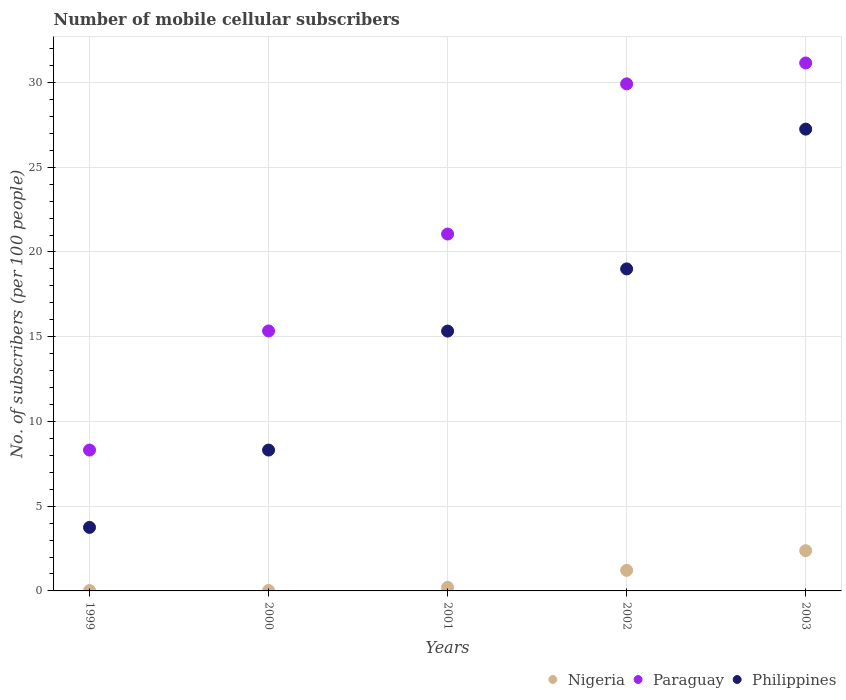How many different coloured dotlines are there?
Give a very brief answer. 3. What is the number of mobile cellular subscribers in Philippines in 2003?
Your answer should be compact. 27.25. Across all years, what is the maximum number of mobile cellular subscribers in Nigeria?
Make the answer very short. 2.38. Across all years, what is the minimum number of mobile cellular subscribers in Philippines?
Offer a terse response. 3.75. In which year was the number of mobile cellular subscribers in Philippines minimum?
Offer a very short reply. 1999. What is the total number of mobile cellular subscribers in Nigeria in the graph?
Your answer should be very brief. 3.85. What is the difference between the number of mobile cellular subscribers in Philippines in 2000 and that in 2003?
Give a very brief answer. -18.94. What is the difference between the number of mobile cellular subscribers in Nigeria in 2003 and the number of mobile cellular subscribers in Philippines in 1999?
Your response must be concise. -1.37. What is the average number of mobile cellular subscribers in Philippines per year?
Your answer should be compact. 14.73. In the year 1999, what is the difference between the number of mobile cellular subscribers in Philippines and number of mobile cellular subscribers in Nigeria?
Offer a terse response. 3.73. In how many years, is the number of mobile cellular subscribers in Philippines greater than 20?
Provide a short and direct response. 1. What is the ratio of the number of mobile cellular subscribers in Nigeria in 1999 to that in 2000?
Provide a short and direct response. 0.85. Is the difference between the number of mobile cellular subscribers in Philippines in 1999 and 2000 greater than the difference between the number of mobile cellular subscribers in Nigeria in 1999 and 2000?
Your response must be concise. No. What is the difference between the highest and the second highest number of mobile cellular subscribers in Nigeria?
Your answer should be very brief. 1.16. What is the difference between the highest and the lowest number of mobile cellular subscribers in Paraguay?
Offer a terse response. 22.84. Is it the case that in every year, the sum of the number of mobile cellular subscribers in Paraguay and number of mobile cellular subscribers in Philippines  is greater than the number of mobile cellular subscribers in Nigeria?
Give a very brief answer. Yes. Is the number of mobile cellular subscribers in Nigeria strictly less than the number of mobile cellular subscribers in Paraguay over the years?
Provide a succinct answer. Yes. Are the values on the major ticks of Y-axis written in scientific E-notation?
Offer a terse response. No. How are the legend labels stacked?
Provide a short and direct response. Horizontal. What is the title of the graph?
Your answer should be compact. Number of mobile cellular subscribers. What is the label or title of the Y-axis?
Give a very brief answer. No. of subscribers (per 100 people). What is the No. of subscribers (per 100 people) of Nigeria in 1999?
Offer a very short reply. 0.02. What is the No. of subscribers (per 100 people) of Paraguay in 1999?
Provide a succinct answer. 8.31. What is the No. of subscribers (per 100 people) of Philippines in 1999?
Keep it short and to the point. 3.75. What is the No. of subscribers (per 100 people) of Nigeria in 2000?
Provide a short and direct response. 0.02. What is the No. of subscribers (per 100 people) of Paraguay in 2000?
Your answer should be very brief. 15.34. What is the No. of subscribers (per 100 people) of Philippines in 2000?
Your response must be concise. 8.31. What is the No. of subscribers (per 100 people) of Nigeria in 2001?
Offer a terse response. 0.21. What is the No. of subscribers (per 100 people) in Paraguay in 2001?
Make the answer very short. 21.06. What is the No. of subscribers (per 100 people) of Philippines in 2001?
Ensure brevity in your answer.  15.33. What is the No. of subscribers (per 100 people) in Nigeria in 2002?
Provide a short and direct response. 1.21. What is the No. of subscribers (per 100 people) of Paraguay in 2002?
Provide a succinct answer. 29.92. What is the No. of subscribers (per 100 people) in Philippines in 2002?
Your answer should be very brief. 19. What is the No. of subscribers (per 100 people) in Nigeria in 2003?
Ensure brevity in your answer.  2.38. What is the No. of subscribers (per 100 people) in Paraguay in 2003?
Ensure brevity in your answer.  31.16. What is the No. of subscribers (per 100 people) of Philippines in 2003?
Keep it short and to the point. 27.25. Across all years, what is the maximum No. of subscribers (per 100 people) in Nigeria?
Provide a short and direct response. 2.38. Across all years, what is the maximum No. of subscribers (per 100 people) of Paraguay?
Ensure brevity in your answer.  31.16. Across all years, what is the maximum No. of subscribers (per 100 people) of Philippines?
Give a very brief answer. 27.25. Across all years, what is the minimum No. of subscribers (per 100 people) in Nigeria?
Give a very brief answer. 0.02. Across all years, what is the minimum No. of subscribers (per 100 people) in Paraguay?
Provide a short and direct response. 8.31. Across all years, what is the minimum No. of subscribers (per 100 people) of Philippines?
Make the answer very short. 3.75. What is the total No. of subscribers (per 100 people) of Nigeria in the graph?
Your response must be concise. 3.85. What is the total No. of subscribers (per 100 people) in Paraguay in the graph?
Provide a short and direct response. 105.79. What is the total No. of subscribers (per 100 people) of Philippines in the graph?
Offer a very short reply. 73.65. What is the difference between the No. of subscribers (per 100 people) in Nigeria in 1999 and that in 2000?
Ensure brevity in your answer.  -0. What is the difference between the No. of subscribers (per 100 people) in Paraguay in 1999 and that in 2000?
Offer a very short reply. -7.03. What is the difference between the No. of subscribers (per 100 people) of Philippines in 1999 and that in 2000?
Provide a succinct answer. -4.56. What is the difference between the No. of subscribers (per 100 people) in Nigeria in 1999 and that in 2001?
Give a very brief answer. -0.19. What is the difference between the No. of subscribers (per 100 people) in Paraguay in 1999 and that in 2001?
Keep it short and to the point. -12.75. What is the difference between the No. of subscribers (per 100 people) in Philippines in 1999 and that in 2001?
Your response must be concise. -11.58. What is the difference between the No. of subscribers (per 100 people) in Nigeria in 1999 and that in 2002?
Provide a succinct answer. -1.19. What is the difference between the No. of subscribers (per 100 people) in Paraguay in 1999 and that in 2002?
Give a very brief answer. -21.61. What is the difference between the No. of subscribers (per 100 people) in Philippines in 1999 and that in 2002?
Offer a terse response. -15.25. What is the difference between the No. of subscribers (per 100 people) of Nigeria in 1999 and that in 2003?
Your response must be concise. -2.36. What is the difference between the No. of subscribers (per 100 people) of Paraguay in 1999 and that in 2003?
Ensure brevity in your answer.  -22.84. What is the difference between the No. of subscribers (per 100 people) of Philippines in 1999 and that in 2003?
Ensure brevity in your answer.  -23.5. What is the difference between the No. of subscribers (per 100 people) of Nigeria in 2000 and that in 2001?
Your answer should be compact. -0.19. What is the difference between the No. of subscribers (per 100 people) in Paraguay in 2000 and that in 2001?
Your answer should be compact. -5.72. What is the difference between the No. of subscribers (per 100 people) of Philippines in 2000 and that in 2001?
Offer a terse response. -7.02. What is the difference between the No. of subscribers (per 100 people) of Nigeria in 2000 and that in 2002?
Provide a short and direct response. -1.19. What is the difference between the No. of subscribers (per 100 people) of Paraguay in 2000 and that in 2002?
Make the answer very short. -14.58. What is the difference between the No. of subscribers (per 100 people) of Philippines in 2000 and that in 2002?
Offer a very short reply. -10.69. What is the difference between the No. of subscribers (per 100 people) of Nigeria in 2000 and that in 2003?
Your answer should be very brief. -2.35. What is the difference between the No. of subscribers (per 100 people) of Paraguay in 2000 and that in 2003?
Offer a very short reply. -15.81. What is the difference between the No. of subscribers (per 100 people) in Philippines in 2000 and that in 2003?
Make the answer very short. -18.94. What is the difference between the No. of subscribers (per 100 people) in Nigeria in 2001 and that in 2002?
Make the answer very short. -1. What is the difference between the No. of subscribers (per 100 people) of Paraguay in 2001 and that in 2002?
Ensure brevity in your answer.  -8.86. What is the difference between the No. of subscribers (per 100 people) in Philippines in 2001 and that in 2002?
Your response must be concise. -3.67. What is the difference between the No. of subscribers (per 100 people) of Nigeria in 2001 and that in 2003?
Ensure brevity in your answer.  -2.16. What is the difference between the No. of subscribers (per 100 people) of Paraguay in 2001 and that in 2003?
Give a very brief answer. -10.1. What is the difference between the No. of subscribers (per 100 people) in Philippines in 2001 and that in 2003?
Make the answer very short. -11.92. What is the difference between the No. of subscribers (per 100 people) of Nigeria in 2002 and that in 2003?
Provide a short and direct response. -1.16. What is the difference between the No. of subscribers (per 100 people) of Paraguay in 2002 and that in 2003?
Offer a terse response. -1.23. What is the difference between the No. of subscribers (per 100 people) in Philippines in 2002 and that in 2003?
Provide a short and direct response. -8.25. What is the difference between the No. of subscribers (per 100 people) in Nigeria in 1999 and the No. of subscribers (per 100 people) in Paraguay in 2000?
Your response must be concise. -15.32. What is the difference between the No. of subscribers (per 100 people) of Nigeria in 1999 and the No. of subscribers (per 100 people) of Philippines in 2000?
Provide a succinct answer. -8.29. What is the difference between the No. of subscribers (per 100 people) of Paraguay in 1999 and the No. of subscribers (per 100 people) of Philippines in 2000?
Your answer should be very brief. 0. What is the difference between the No. of subscribers (per 100 people) of Nigeria in 1999 and the No. of subscribers (per 100 people) of Paraguay in 2001?
Offer a very short reply. -21.04. What is the difference between the No. of subscribers (per 100 people) of Nigeria in 1999 and the No. of subscribers (per 100 people) of Philippines in 2001?
Your answer should be very brief. -15.31. What is the difference between the No. of subscribers (per 100 people) in Paraguay in 1999 and the No. of subscribers (per 100 people) in Philippines in 2001?
Give a very brief answer. -7.02. What is the difference between the No. of subscribers (per 100 people) of Nigeria in 1999 and the No. of subscribers (per 100 people) of Paraguay in 2002?
Make the answer very short. -29.9. What is the difference between the No. of subscribers (per 100 people) of Nigeria in 1999 and the No. of subscribers (per 100 people) of Philippines in 2002?
Provide a succinct answer. -18.98. What is the difference between the No. of subscribers (per 100 people) in Paraguay in 1999 and the No. of subscribers (per 100 people) in Philippines in 2002?
Give a very brief answer. -10.69. What is the difference between the No. of subscribers (per 100 people) of Nigeria in 1999 and the No. of subscribers (per 100 people) of Paraguay in 2003?
Offer a terse response. -31.13. What is the difference between the No. of subscribers (per 100 people) in Nigeria in 1999 and the No. of subscribers (per 100 people) in Philippines in 2003?
Your answer should be very brief. -27.23. What is the difference between the No. of subscribers (per 100 people) in Paraguay in 1999 and the No. of subscribers (per 100 people) in Philippines in 2003?
Provide a short and direct response. -18.94. What is the difference between the No. of subscribers (per 100 people) in Nigeria in 2000 and the No. of subscribers (per 100 people) in Paraguay in 2001?
Offer a very short reply. -21.04. What is the difference between the No. of subscribers (per 100 people) in Nigeria in 2000 and the No. of subscribers (per 100 people) in Philippines in 2001?
Provide a succinct answer. -15.31. What is the difference between the No. of subscribers (per 100 people) of Paraguay in 2000 and the No. of subscribers (per 100 people) of Philippines in 2001?
Give a very brief answer. 0.01. What is the difference between the No. of subscribers (per 100 people) of Nigeria in 2000 and the No. of subscribers (per 100 people) of Paraguay in 2002?
Offer a very short reply. -29.9. What is the difference between the No. of subscribers (per 100 people) in Nigeria in 2000 and the No. of subscribers (per 100 people) in Philippines in 2002?
Ensure brevity in your answer.  -18.98. What is the difference between the No. of subscribers (per 100 people) in Paraguay in 2000 and the No. of subscribers (per 100 people) in Philippines in 2002?
Your answer should be very brief. -3.66. What is the difference between the No. of subscribers (per 100 people) in Nigeria in 2000 and the No. of subscribers (per 100 people) in Paraguay in 2003?
Your response must be concise. -31.13. What is the difference between the No. of subscribers (per 100 people) of Nigeria in 2000 and the No. of subscribers (per 100 people) of Philippines in 2003?
Your response must be concise. -27.23. What is the difference between the No. of subscribers (per 100 people) in Paraguay in 2000 and the No. of subscribers (per 100 people) in Philippines in 2003?
Your response must be concise. -11.91. What is the difference between the No. of subscribers (per 100 people) of Nigeria in 2001 and the No. of subscribers (per 100 people) of Paraguay in 2002?
Offer a terse response. -29.71. What is the difference between the No. of subscribers (per 100 people) in Nigeria in 2001 and the No. of subscribers (per 100 people) in Philippines in 2002?
Ensure brevity in your answer.  -18.79. What is the difference between the No. of subscribers (per 100 people) in Paraguay in 2001 and the No. of subscribers (per 100 people) in Philippines in 2002?
Your answer should be very brief. 2.06. What is the difference between the No. of subscribers (per 100 people) of Nigeria in 2001 and the No. of subscribers (per 100 people) of Paraguay in 2003?
Keep it short and to the point. -30.94. What is the difference between the No. of subscribers (per 100 people) in Nigeria in 2001 and the No. of subscribers (per 100 people) in Philippines in 2003?
Keep it short and to the point. -27.04. What is the difference between the No. of subscribers (per 100 people) of Paraguay in 2001 and the No. of subscribers (per 100 people) of Philippines in 2003?
Offer a very short reply. -6.19. What is the difference between the No. of subscribers (per 100 people) of Nigeria in 2002 and the No. of subscribers (per 100 people) of Paraguay in 2003?
Ensure brevity in your answer.  -29.94. What is the difference between the No. of subscribers (per 100 people) of Nigeria in 2002 and the No. of subscribers (per 100 people) of Philippines in 2003?
Provide a short and direct response. -26.04. What is the difference between the No. of subscribers (per 100 people) in Paraguay in 2002 and the No. of subscribers (per 100 people) in Philippines in 2003?
Make the answer very short. 2.67. What is the average No. of subscribers (per 100 people) of Nigeria per year?
Your answer should be compact. 0.77. What is the average No. of subscribers (per 100 people) in Paraguay per year?
Offer a very short reply. 21.16. What is the average No. of subscribers (per 100 people) of Philippines per year?
Provide a short and direct response. 14.73. In the year 1999, what is the difference between the No. of subscribers (per 100 people) in Nigeria and No. of subscribers (per 100 people) in Paraguay?
Provide a succinct answer. -8.29. In the year 1999, what is the difference between the No. of subscribers (per 100 people) in Nigeria and No. of subscribers (per 100 people) in Philippines?
Keep it short and to the point. -3.73. In the year 1999, what is the difference between the No. of subscribers (per 100 people) of Paraguay and No. of subscribers (per 100 people) of Philippines?
Your answer should be compact. 4.56. In the year 2000, what is the difference between the No. of subscribers (per 100 people) in Nigeria and No. of subscribers (per 100 people) in Paraguay?
Make the answer very short. -15.32. In the year 2000, what is the difference between the No. of subscribers (per 100 people) in Nigeria and No. of subscribers (per 100 people) in Philippines?
Provide a short and direct response. -8.29. In the year 2000, what is the difference between the No. of subscribers (per 100 people) of Paraguay and No. of subscribers (per 100 people) of Philippines?
Make the answer very short. 7.03. In the year 2001, what is the difference between the No. of subscribers (per 100 people) in Nigeria and No. of subscribers (per 100 people) in Paraguay?
Provide a succinct answer. -20.85. In the year 2001, what is the difference between the No. of subscribers (per 100 people) in Nigeria and No. of subscribers (per 100 people) in Philippines?
Make the answer very short. -15.12. In the year 2001, what is the difference between the No. of subscribers (per 100 people) of Paraguay and No. of subscribers (per 100 people) of Philippines?
Offer a terse response. 5.73. In the year 2002, what is the difference between the No. of subscribers (per 100 people) of Nigeria and No. of subscribers (per 100 people) of Paraguay?
Provide a short and direct response. -28.71. In the year 2002, what is the difference between the No. of subscribers (per 100 people) in Nigeria and No. of subscribers (per 100 people) in Philippines?
Provide a succinct answer. -17.79. In the year 2002, what is the difference between the No. of subscribers (per 100 people) of Paraguay and No. of subscribers (per 100 people) of Philippines?
Make the answer very short. 10.92. In the year 2003, what is the difference between the No. of subscribers (per 100 people) of Nigeria and No. of subscribers (per 100 people) of Paraguay?
Your answer should be very brief. -28.78. In the year 2003, what is the difference between the No. of subscribers (per 100 people) in Nigeria and No. of subscribers (per 100 people) in Philippines?
Provide a short and direct response. -24.87. In the year 2003, what is the difference between the No. of subscribers (per 100 people) in Paraguay and No. of subscribers (per 100 people) in Philippines?
Ensure brevity in your answer.  3.91. What is the ratio of the No. of subscribers (per 100 people) of Nigeria in 1999 to that in 2000?
Give a very brief answer. 0.85. What is the ratio of the No. of subscribers (per 100 people) in Paraguay in 1999 to that in 2000?
Offer a very short reply. 0.54. What is the ratio of the No. of subscribers (per 100 people) in Philippines in 1999 to that in 2000?
Keep it short and to the point. 0.45. What is the ratio of the No. of subscribers (per 100 people) in Nigeria in 1999 to that in 2001?
Your answer should be compact. 0.1. What is the ratio of the No. of subscribers (per 100 people) of Paraguay in 1999 to that in 2001?
Keep it short and to the point. 0.39. What is the ratio of the No. of subscribers (per 100 people) in Philippines in 1999 to that in 2001?
Ensure brevity in your answer.  0.24. What is the ratio of the No. of subscribers (per 100 people) in Nigeria in 1999 to that in 2002?
Provide a short and direct response. 0.02. What is the ratio of the No. of subscribers (per 100 people) in Paraguay in 1999 to that in 2002?
Provide a short and direct response. 0.28. What is the ratio of the No. of subscribers (per 100 people) in Philippines in 1999 to that in 2002?
Give a very brief answer. 0.2. What is the ratio of the No. of subscribers (per 100 people) of Nigeria in 1999 to that in 2003?
Provide a short and direct response. 0.01. What is the ratio of the No. of subscribers (per 100 people) of Paraguay in 1999 to that in 2003?
Provide a succinct answer. 0.27. What is the ratio of the No. of subscribers (per 100 people) of Philippines in 1999 to that in 2003?
Your answer should be very brief. 0.14. What is the ratio of the No. of subscribers (per 100 people) in Nigeria in 2000 to that in 2001?
Offer a very short reply. 0.12. What is the ratio of the No. of subscribers (per 100 people) in Paraguay in 2000 to that in 2001?
Give a very brief answer. 0.73. What is the ratio of the No. of subscribers (per 100 people) in Philippines in 2000 to that in 2001?
Your answer should be compact. 0.54. What is the ratio of the No. of subscribers (per 100 people) of Nigeria in 2000 to that in 2002?
Provide a short and direct response. 0.02. What is the ratio of the No. of subscribers (per 100 people) of Paraguay in 2000 to that in 2002?
Your answer should be very brief. 0.51. What is the ratio of the No. of subscribers (per 100 people) in Philippines in 2000 to that in 2002?
Your answer should be very brief. 0.44. What is the ratio of the No. of subscribers (per 100 people) in Nigeria in 2000 to that in 2003?
Offer a very short reply. 0.01. What is the ratio of the No. of subscribers (per 100 people) in Paraguay in 2000 to that in 2003?
Provide a short and direct response. 0.49. What is the ratio of the No. of subscribers (per 100 people) of Philippines in 2000 to that in 2003?
Give a very brief answer. 0.3. What is the ratio of the No. of subscribers (per 100 people) in Nigeria in 2001 to that in 2002?
Offer a very short reply. 0.17. What is the ratio of the No. of subscribers (per 100 people) in Paraguay in 2001 to that in 2002?
Offer a terse response. 0.7. What is the ratio of the No. of subscribers (per 100 people) of Philippines in 2001 to that in 2002?
Make the answer very short. 0.81. What is the ratio of the No. of subscribers (per 100 people) in Nigeria in 2001 to that in 2003?
Your response must be concise. 0.09. What is the ratio of the No. of subscribers (per 100 people) in Paraguay in 2001 to that in 2003?
Offer a very short reply. 0.68. What is the ratio of the No. of subscribers (per 100 people) in Philippines in 2001 to that in 2003?
Offer a terse response. 0.56. What is the ratio of the No. of subscribers (per 100 people) in Nigeria in 2002 to that in 2003?
Ensure brevity in your answer.  0.51. What is the ratio of the No. of subscribers (per 100 people) of Paraguay in 2002 to that in 2003?
Your answer should be compact. 0.96. What is the ratio of the No. of subscribers (per 100 people) of Philippines in 2002 to that in 2003?
Make the answer very short. 0.7. What is the difference between the highest and the second highest No. of subscribers (per 100 people) of Nigeria?
Your answer should be very brief. 1.16. What is the difference between the highest and the second highest No. of subscribers (per 100 people) in Paraguay?
Keep it short and to the point. 1.23. What is the difference between the highest and the second highest No. of subscribers (per 100 people) in Philippines?
Offer a terse response. 8.25. What is the difference between the highest and the lowest No. of subscribers (per 100 people) in Nigeria?
Your response must be concise. 2.36. What is the difference between the highest and the lowest No. of subscribers (per 100 people) in Paraguay?
Make the answer very short. 22.84. What is the difference between the highest and the lowest No. of subscribers (per 100 people) in Philippines?
Your response must be concise. 23.5. 